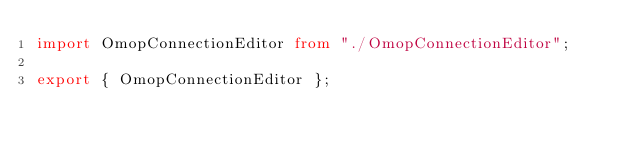<code> <loc_0><loc_0><loc_500><loc_500><_TypeScript_>import OmopConnectionEditor from "./OmopConnectionEditor";

export { OmopConnectionEditor };
</code> 